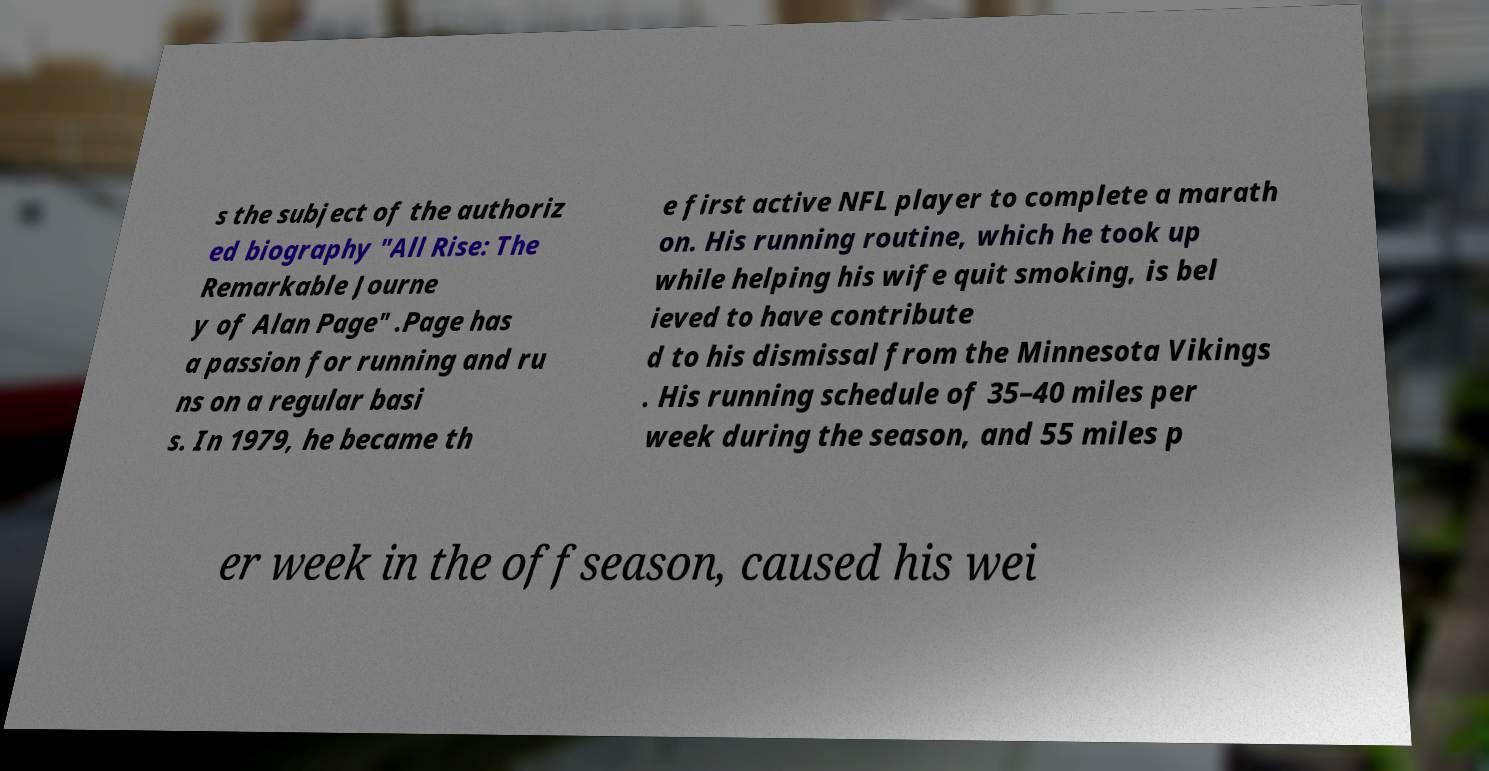Please read and relay the text visible in this image. What does it say? s the subject of the authoriz ed biography "All Rise: The Remarkable Journe y of Alan Page" .Page has a passion for running and ru ns on a regular basi s. In 1979, he became th e first active NFL player to complete a marath on. His running routine, which he took up while helping his wife quit smoking, is bel ieved to have contribute d to his dismissal from the Minnesota Vikings . His running schedule of 35–40 miles per week during the season, and 55 miles p er week in the offseason, caused his wei 